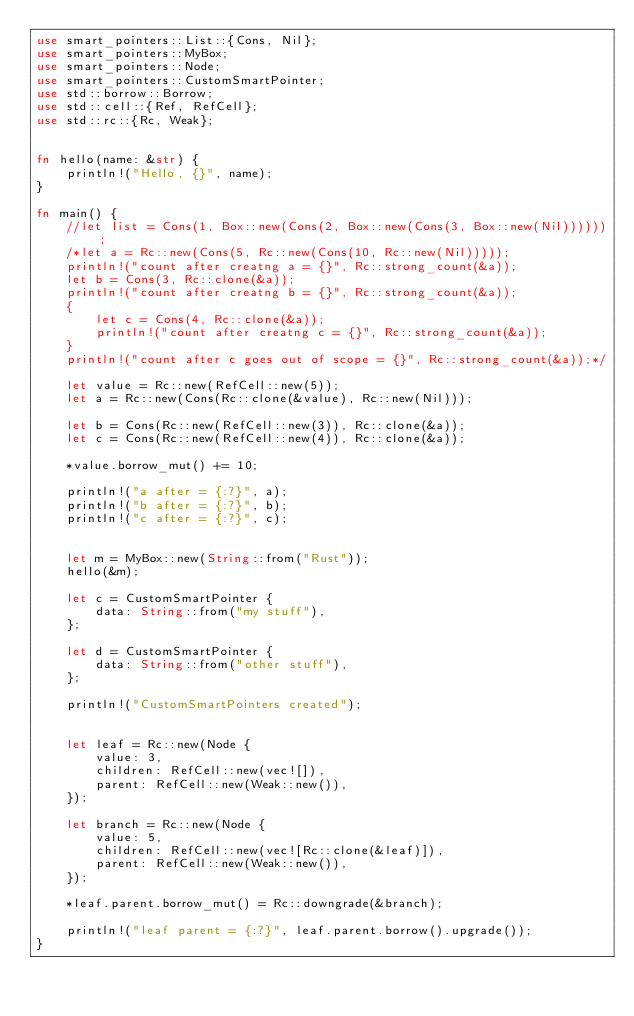<code> <loc_0><loc_0><loc_500><loc_500><_Rust_>use smart_pointers::List::{Cons, Nil};
use smart_pointers::MyBox;
use smart_pointers::Node;
use smart_pointers::CustomSmartPointer;
use std::borrow::Borrow;
use std::cell::{Ref, RefCell};
use std::rc::{Rc, Weak};


fn hello(name: &str) {
    println!("Hello, {}", name);
}

fn main() {
    //let list = Cons(1, Box::new(Cons(2, Box::new(Cons(3, Box::new(Nil))))));
    /*let a = Rc::new(Cons(5, Rc::new(Cons(10, Rc::new(Nil)))));
    println!("count after creatng a = {}", Rc::strong_count(&a));
    let b = Cons(3, Rc::clone(&a));
    println!("count after creatng b = {}", Rc::strong_count(&a));
    {
        let c = Cons(4, Rc::clone(&a));
        println!("count after creatng c = {}", Rc::strong_count(&a));
    }
    println!("count after c goes out of scope = {}", Rc::strong_count(&a));*/

    let value = Rc::new(RefCell::new(5));
    let a = Rc::new(Cons(Rc::clone(&value), Rc::new(Nil)));

    let b = Cons(Rc::new(RefCell::new(3)), Rc::clone(&a));
    let c = Cons(Rc::new(RefCell::new(4)), Rc::clone(&a));

    *value.borrow_mut() += 10;

    println!("a after = {:?}", a);
    println!("b after = {:?}", b);
    println!("c after = {:?}", c);


    let m = MyBox::new(String::from("Rust"));
    hello(&m);

    let c = CustomSmartPointer {
        data: String::from("my stuff"),
    };

    let d = CustomSmartPointer {
        data: String::from("other stuff"),
    };

    println!("CustomSmartPointers created");


    let leaf = Rc::new(Node {
        value: 3,
        children: RefCell::new(vec![]),
        parent: RefCell::new(Weak::new()),
    });

    let branch = Rc::new(Node {
        value: 5,
        children: RefCell::new(vec![Rc::clone(&leaf)]),
        parent: RefCell::new(Weak::new()),
    });

    *leaf.parent.borrow_mut() = Rc::downgrade(&branch);

    println!("leaf parent = {:?}", leaf.parent.borrow().upgrade());
}
</code> 